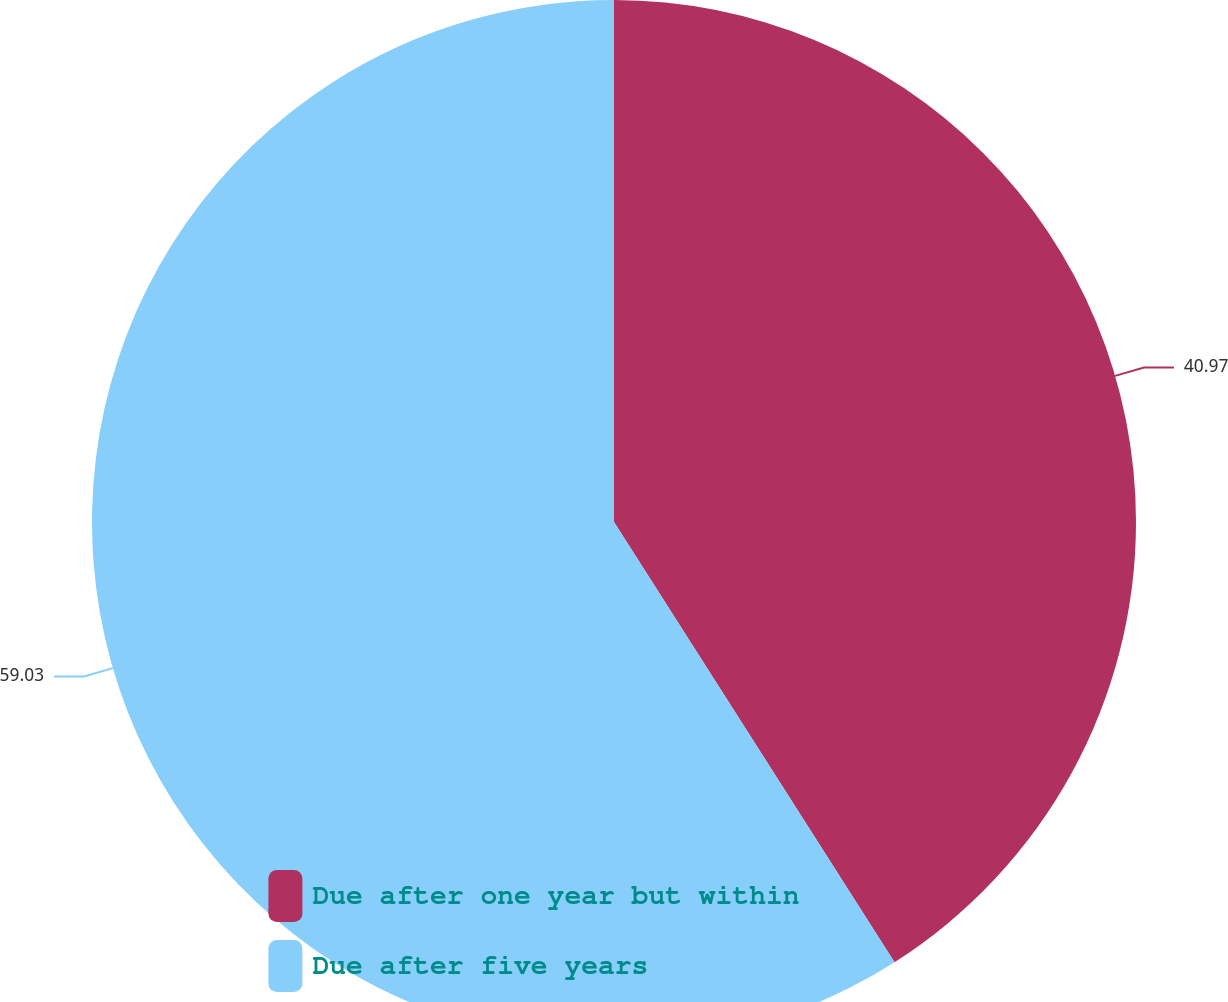<chart> <loc_0><loc_0><loc_500><loc_500><pie_chart><fcel>Due after one year but within<fcel>Due after five years<nl><fcel>40.97%<fcel>59.03%<nl></chart> 